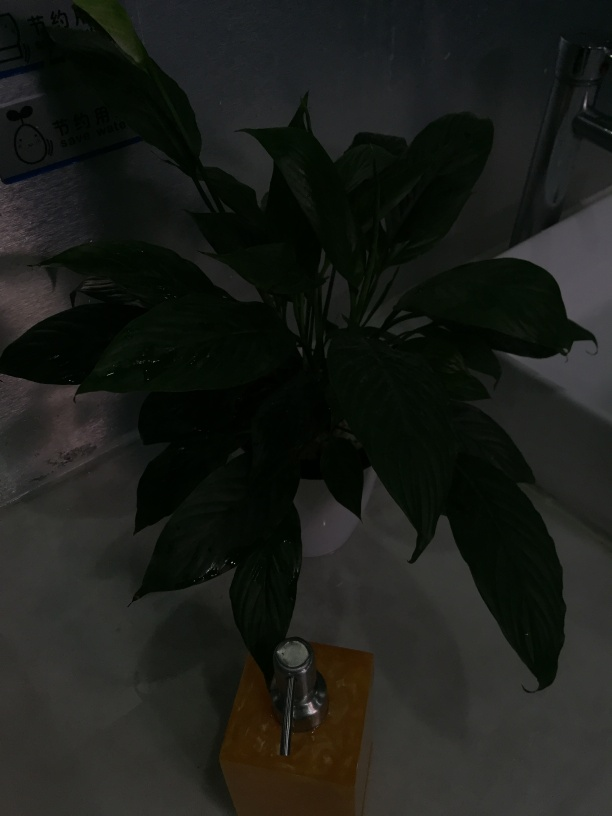Is the color balance in the image satisfactory? No, the image appears to be underexposed, resulting in an overall dark appearance that obscures details. Improving the exposure could significantly enhance the visibility of the plant's features and the surrounding context. 